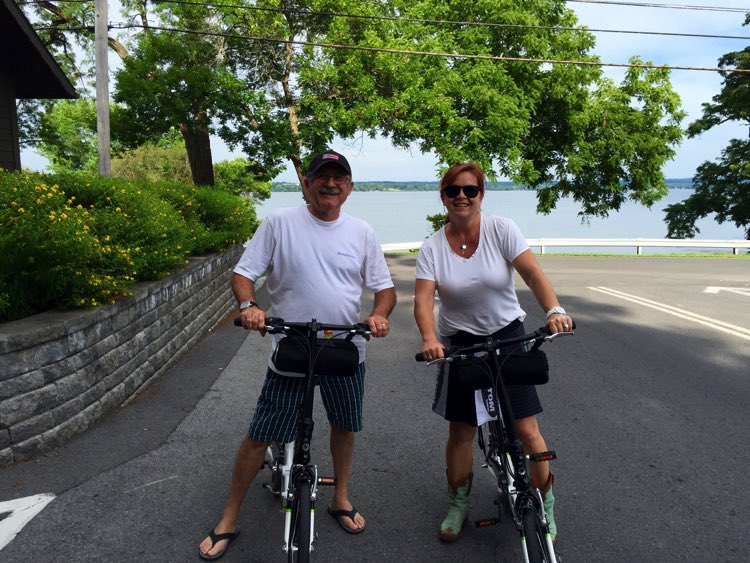Can you describe the type of attire the cyclists are wearing and what it might suggest about their ride? Certainly! The cyclists are wearing casual attire; the man is in a white t-shirt and patterned shorts, while the woman sports a white top and black shorts. Neither are wearing specialized cycling gear, which along with their sandals and sunglasses signifies an informal ride, perhaps along the lakeside for relaxation rather than for fitness or sport. 